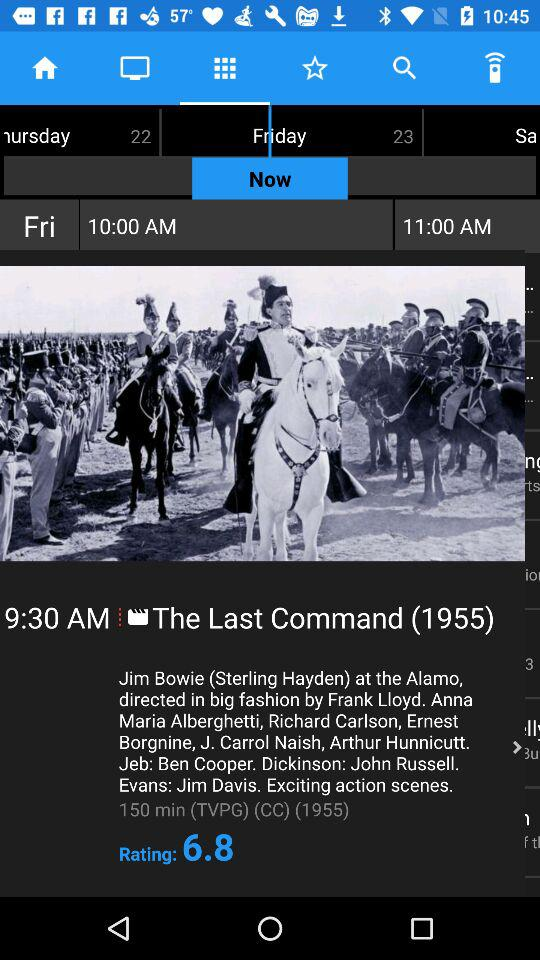What is the rating of the movie? The rating of the movie is 6.8. 